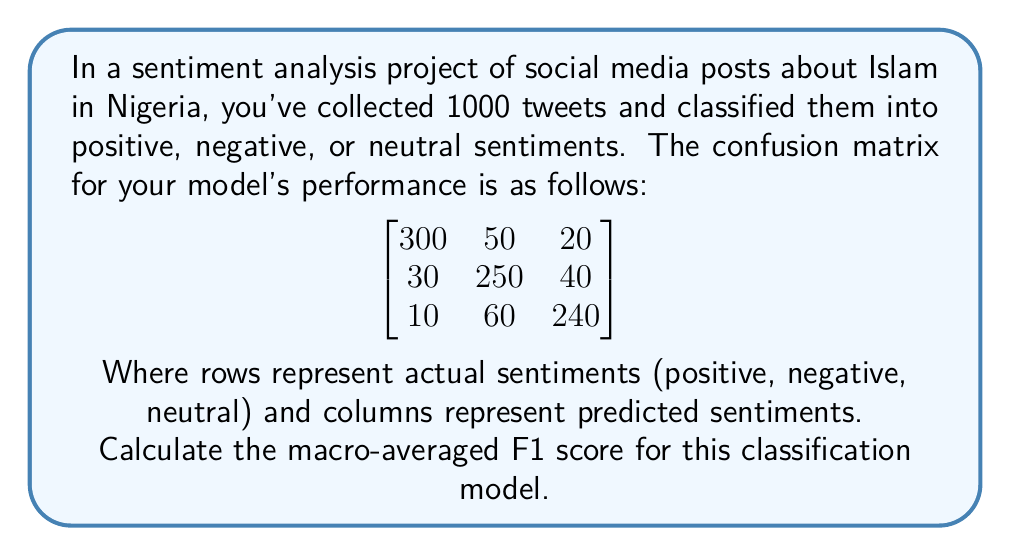Give your solution to this math problem. To calculate the macro-averaged F1 score, we need to follow these steps:

1. Calculate precision and recall for each class:

   For positive sentiment:
   Precision = $\frac{300}{300+30+10} = \frac{300}{340} = 0.8824$
   Recall = $\frac{300}{300+50+20} = \frac{300}{370} = 0.8108$

   For negative sentiment:
   Precision = $\frac{250}{50+250+60} = \frac{250}{360} = 0.6944$
   Recall = $\frac{250}{30+250+40} = \frac{250}{320} = 0.7813$

   For neutral sentiment:
   Precision = $\frac{240}{20+40+240} = \frac{240}{300} = 0.8000$
   Recall = $\frac{240}{10+60+240} = \frac{240}{310} = 0.7742$

2. Calculate F1 score for each class:
   F1 = $\frac{2 * precision * recall}{precision + recall}$

   Positive: F1 = $\frac{2 * 0.8824 * 0.8108}{0.8824 + 0.8108} = 0.8451$
   Negative: F1 = $\frac{2 * 0.6944 * 0.7813}{0.6944 + 0.7813} = 0.7353$
   Neutral: F1 = $\frac{2 * 0.8000 * 0.7742}{0.8000 + 0.7742} = 0.7869$

3. Calculate macro-averaged F1 score:
   Macro-avg F1 = $\frac{F1_{positive} + F1_{negative} + F1_{neutral}}{3}$
   
   Macro-avg F1 = $\frac{0.8451 + 0.7353 + 0.7869}{3} = 0.7891$
Answer: 0.7891 